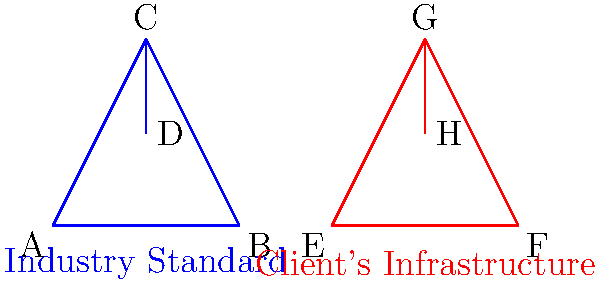Analyze the network topology diagrams comparing the client's infrastructure (right, in red) to industry standards (left, in blue). What key difference in redundancy could you argue makes the client's network more vulnerable to failures? To answer this question, we need to examine both network topologies carefully:

1. Industry Standard Topology (Blue):
   - It forms a full triangle between nodes A, B, and C.
   - There's an additional connection from C to D.
   - This creates multiple paths between any two nodes.

2. Client's Infrastructure (Red):
   - It forms a triangle between nodes E, F, and G.
   - There's an additional connection from G to H.
   - However, there's also a direct connection between E and F.

3. Redundancy Comparison:
   - In the industry standard, if any single link fails, all nodes remain connected.
   - In the client's infrastructure, if the link G-H fails, H becomes isolated.

4. Vulnerability Analysis:
   - The client's topology has a single point of failure for node H.
   - If the G-H link fails, H loses all connectivity to the network.

5. Legal Implication:
   - As a lawyer, you could argue that this lack of redundancy for node H makes the client's network more vulnerable to failures.
   - This could potentially lead to service interruptions or data loss, which might not meet industry standards for reliability and resilience.
Answer: Single point of failure for node H 